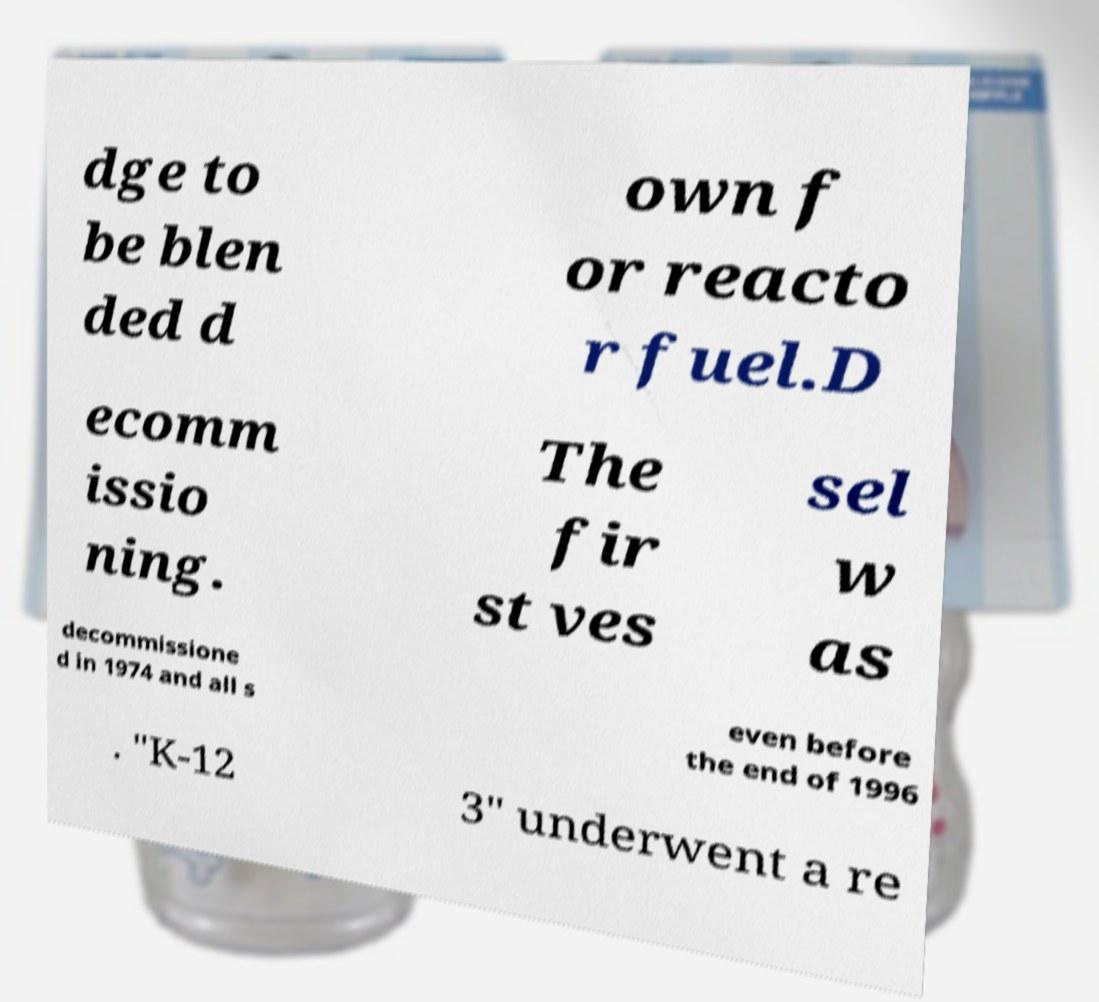Could you assist in decoding the text presented in this image and type it out clearly? dge to be blen ded d own f or reacto r fuel.D ecomm issio ning. The fir st ves sel w as decommissione d in 1974 and all s even before the end of 1996 . "K-12 3" underwent a re 